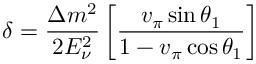Convert formula to latex. <formula><loc_0><loc_0><loc_500><loc_500>\delta = \frac { \Delta m ^ { 2 } } { 2 E _ { \nu } ^ { 2 } } \left [ \frac { v _ { \pi } \sin \theta _ { 1 } } { 1 - v _ { \pi } \cos \theta _ { 1 } } \right ]</formula> 